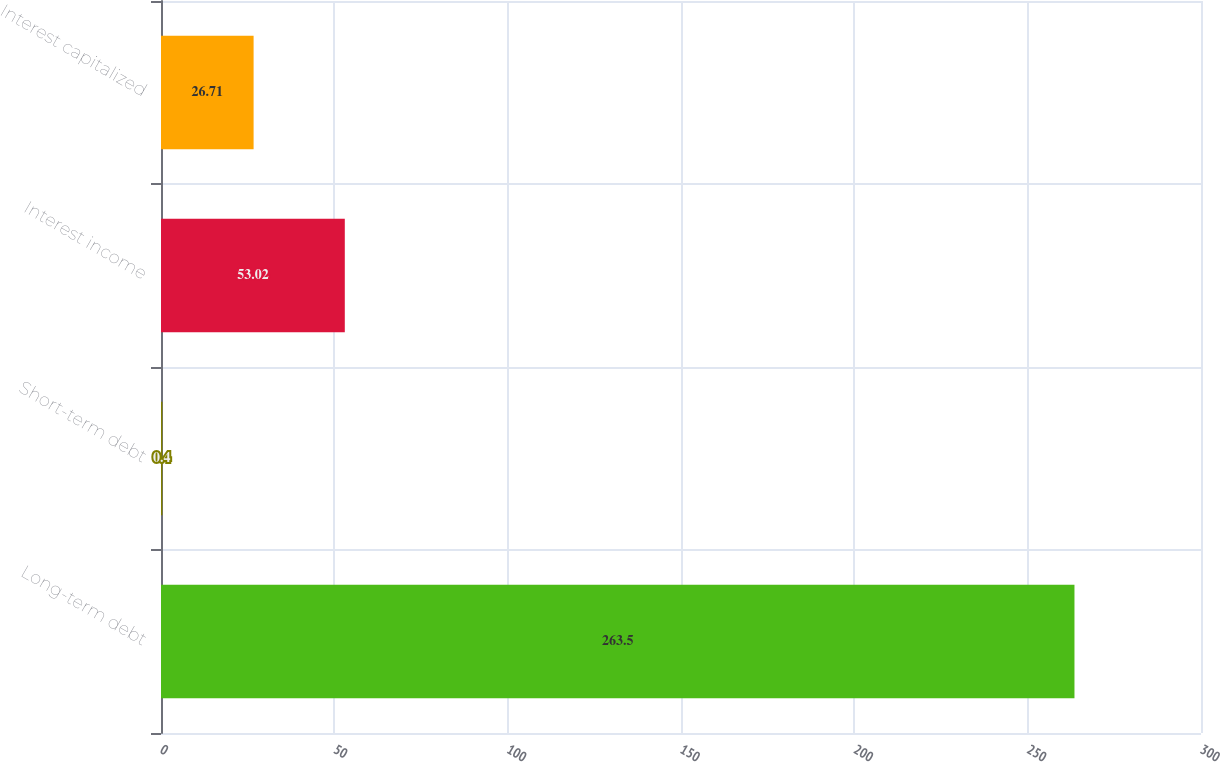Convert chart. <chart><loc_0><loc_0><loc_500><loc_500><bar_chart><fcel>Long-term debt<fcel>Short-term debt<fcel>Interest income<fcel>Interest capitalized<nl><fcel>263.5<fcel>0.4<fcel>53.02<fcel>26.71<nl></chart> 